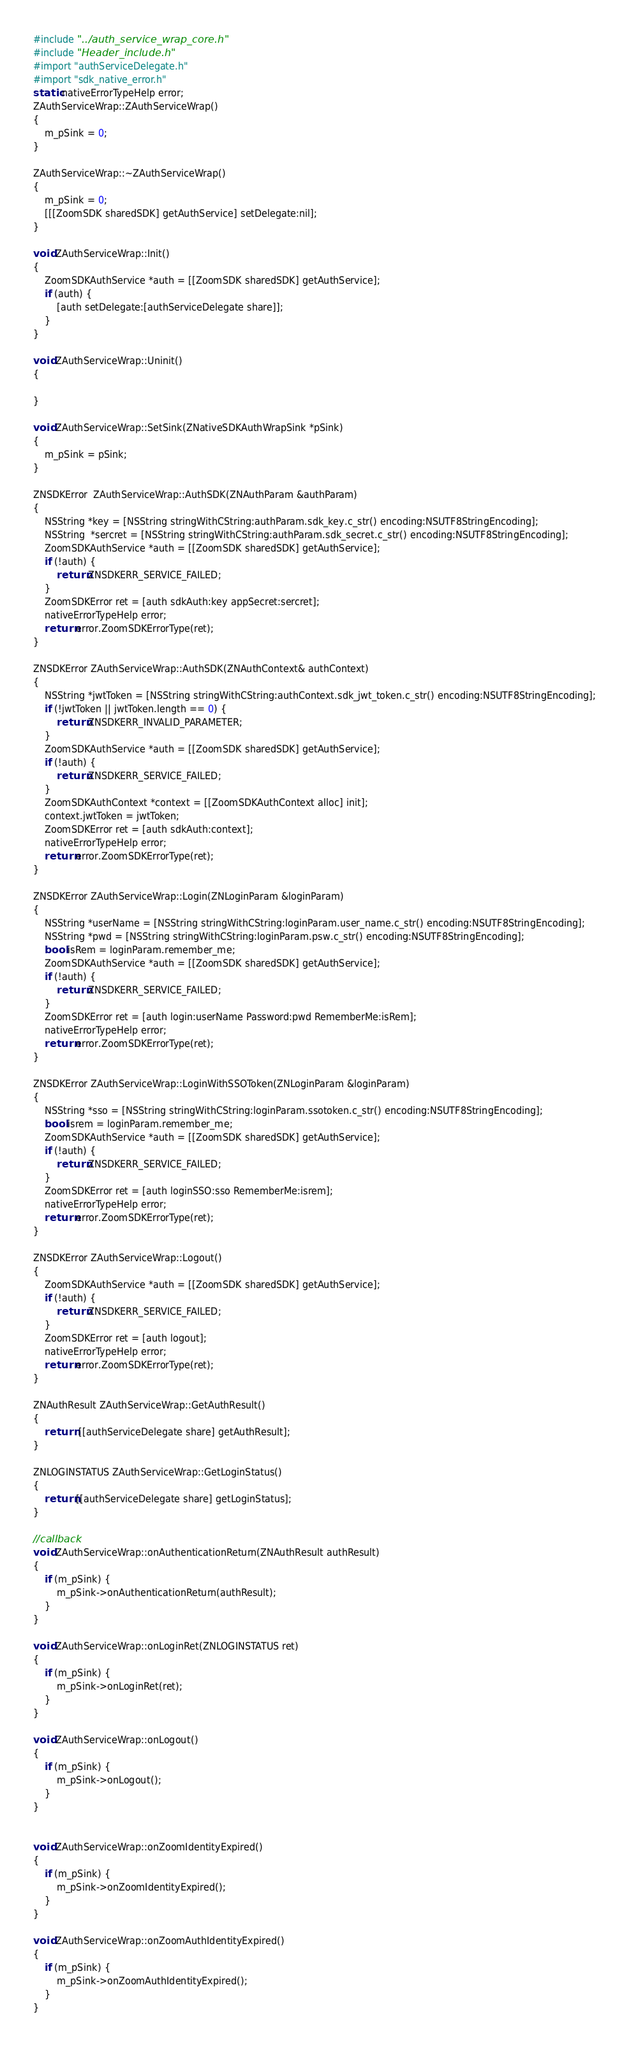<code> <loc_0><loc_0><loc_500><loc_500><_ObjectiveC_>

#include "../auth_service_wrap_core.h"
#include "Header_include.h"
#import "authServiceDelegate.h"
#import "sdk_native_error.h"
static nativeErrorTypeHelp error;
ZAuthServiceWrap::ZAuthServiceWrap()
{
    m_pSink = 0;
}

ZAuthServiceWrap::~ZAuthServiceWrap()
{
    m_pSink = 0;
    [[[ZoomSDK sharedSDK] getAuthService] setDelegate:nil];
}

void ZAuthServiceWrap::Init()
{
    ZoomSDKAuthService *auth = [[ZoomSDK sharedSDK] getAuthService];
    if (auth) {
        [auth setDelegate:[authServiceDelegate share]];
    }
}

void ZAuthServiceWrap::Uninit()
{

}

void ZAuthServiceWrap::SetSink(ZNativeSDKAuthWrapSink *pSink)
{
    m_pSink = pSink;
}

ZNSDKError  ZAuthServiceWrap::AuthSDK(ZNAuthParam &authParam)
{
    NSString *key = [NSString stringWithCString:authParam.sdk_key.c_str() encoding:NSUTF8StringEncoding];
    NSString  *sercret = [NSString stringWithCString:authParam.sdk_secret.c_str() encoding:NSUTF8StringEncoding];
    ZoomSDKAuthService *auth = [[ZoomSDK sharedSDK] getAuthService];
    if (!auth) {
        return ZNSDKERR_SERVICE_FAILED;
    }
    ZoomSDKError ret = [auth sdkAuth:key appSecret:sercret];
    nativeErrorTypeHelp error;
    return error.ZoomSDKErrorType(ret);
}

ZNSDKError ZAuthServiceWrap::AuthSDK(ZNAuthContext& authContext)
{
    NSString *jwtToken = [NSString stringWithCString:authContext.sdk_jwt_token.c_str() encoding:NSUTF8StringEncoding];
    if (!jwtToken || jwtToken.length == 0) {
        return ZNSDKERR_INVALID_PARAMETER;
    }
    ZoomSDKAuthService *auth = [[ZoomSDK sharedSDK] getAuthService];
    if (!auth) {
        return ZNSDKERR_SERVICE_FAILED;
    }
    ZoomSDKAuthContext *context = [[ZoomSDKAuthContext alloc] init];
    context.jwtToken = jwtToken;
    ZoomSDKError ret = [auth sdkAuth:context];
    nativeErrorTypeHelp error;
    return error.ZoomSDKErrorType(ret);
}

ZNSDKError ZAuthServiceWrap::Login(ZNLoginParam &loginParam)
{
    NSString *userName = [NSString stringWithCString:loginParam.user_name.c_str() encoding:NSUTF8StringEncoding];
    NSString *pwd = [NSString stringWithCString:loginParam.psw.c_str() encoding:NSUTF8StringEncoding];
    bool isRem = loginParam.remember_me;
    ZoomSDKAuthService *auth = [[ZoomSDK sharedSDK] getAuthService];
    if (!auth) {
        return ZNSDKERR_SERVICE_FAILED;
    }
    ZoomSDKError ret = [auth login:userName Password:pwd RememberMe:isRem];
    nativeErrorTypeHelp error;
    return error.ZoomSDKErrorType(ret);
}

ZNSDKError ZAuthServiceWrap::LoginWithSSOToken(ZNLoginParam &loginParam)
{
    NSString *sso = [NSString stringWithCString:loginParam.ssotoken.c_str() encoding:NSUTF8StringEncoding];
    bool isrem = loginParam.remember_me;
    ZoomSDKAuthService *auth = [[ZoomSDK sharedSDK] getAuthService];
    if (!auth) {
        return ZNSDKERR_SERVICE_FAILED;
    }
    ZoomSDKError ret = [auth loginSSO:sso RememberMe:isrem];
    nativeErrorTypeHelp error;
    return error.ZoomSDKErrorType(ret);
}

ZNSDKError ZAuthServiceWrap::Logout()
{
    ZoomSDKAuthService *auth = [[ZoomSDK sharedSDK] getAuthService];
    if (!auth) {
        return ZNSDKERR_SERVICE_FAILED;
    }
    ZoomSDKError ret = [auth logout];
    nativeErrorTypeHelp error;
    return error.ZoomSDKErrorType(ret);
}

ZNAuthResult ZAuthServiceWrap::GetAuthResult()
{
    return  [[authServiceDelegate share] getAuthResult];
}

ZNLOGINSTATUS ZAuthServiceWrap::GetLoginStatus()
{
    return [[authServiceDelegate share] getLoginStatus];
}

//callback
void ZAuthServiceWrap::onAuthenticationReturn(ZNAuthResult authResult)
{
    if (m_pSink) {
        m_pSink->onAuthenticationReturn(authResult);
    }
}

void ZAuthServiceWrap::onLoginRet(ZNLOGINSTATUS ret)
{
    if (m_pSink) {
        m_pSink->onLoginRet(ret);
    }
}

void ZAuthServiceWrap::onLogout()
{
    if (m_pSink) {
        m_pSink->onLogout();
    }
}


void ZAuthServiceWrap::onZoomIdentityExpired()
{
    if (m_pSink) {
        m_pSink->onZoomIdentityExpired();
    }
}

void ZAuthServiceWrap::onZoomAuthIdentityExpired()
{
    if (m_pSink) {
        m_pSink->onZoomAuthIdentityExpired();
    }
}


</code> 